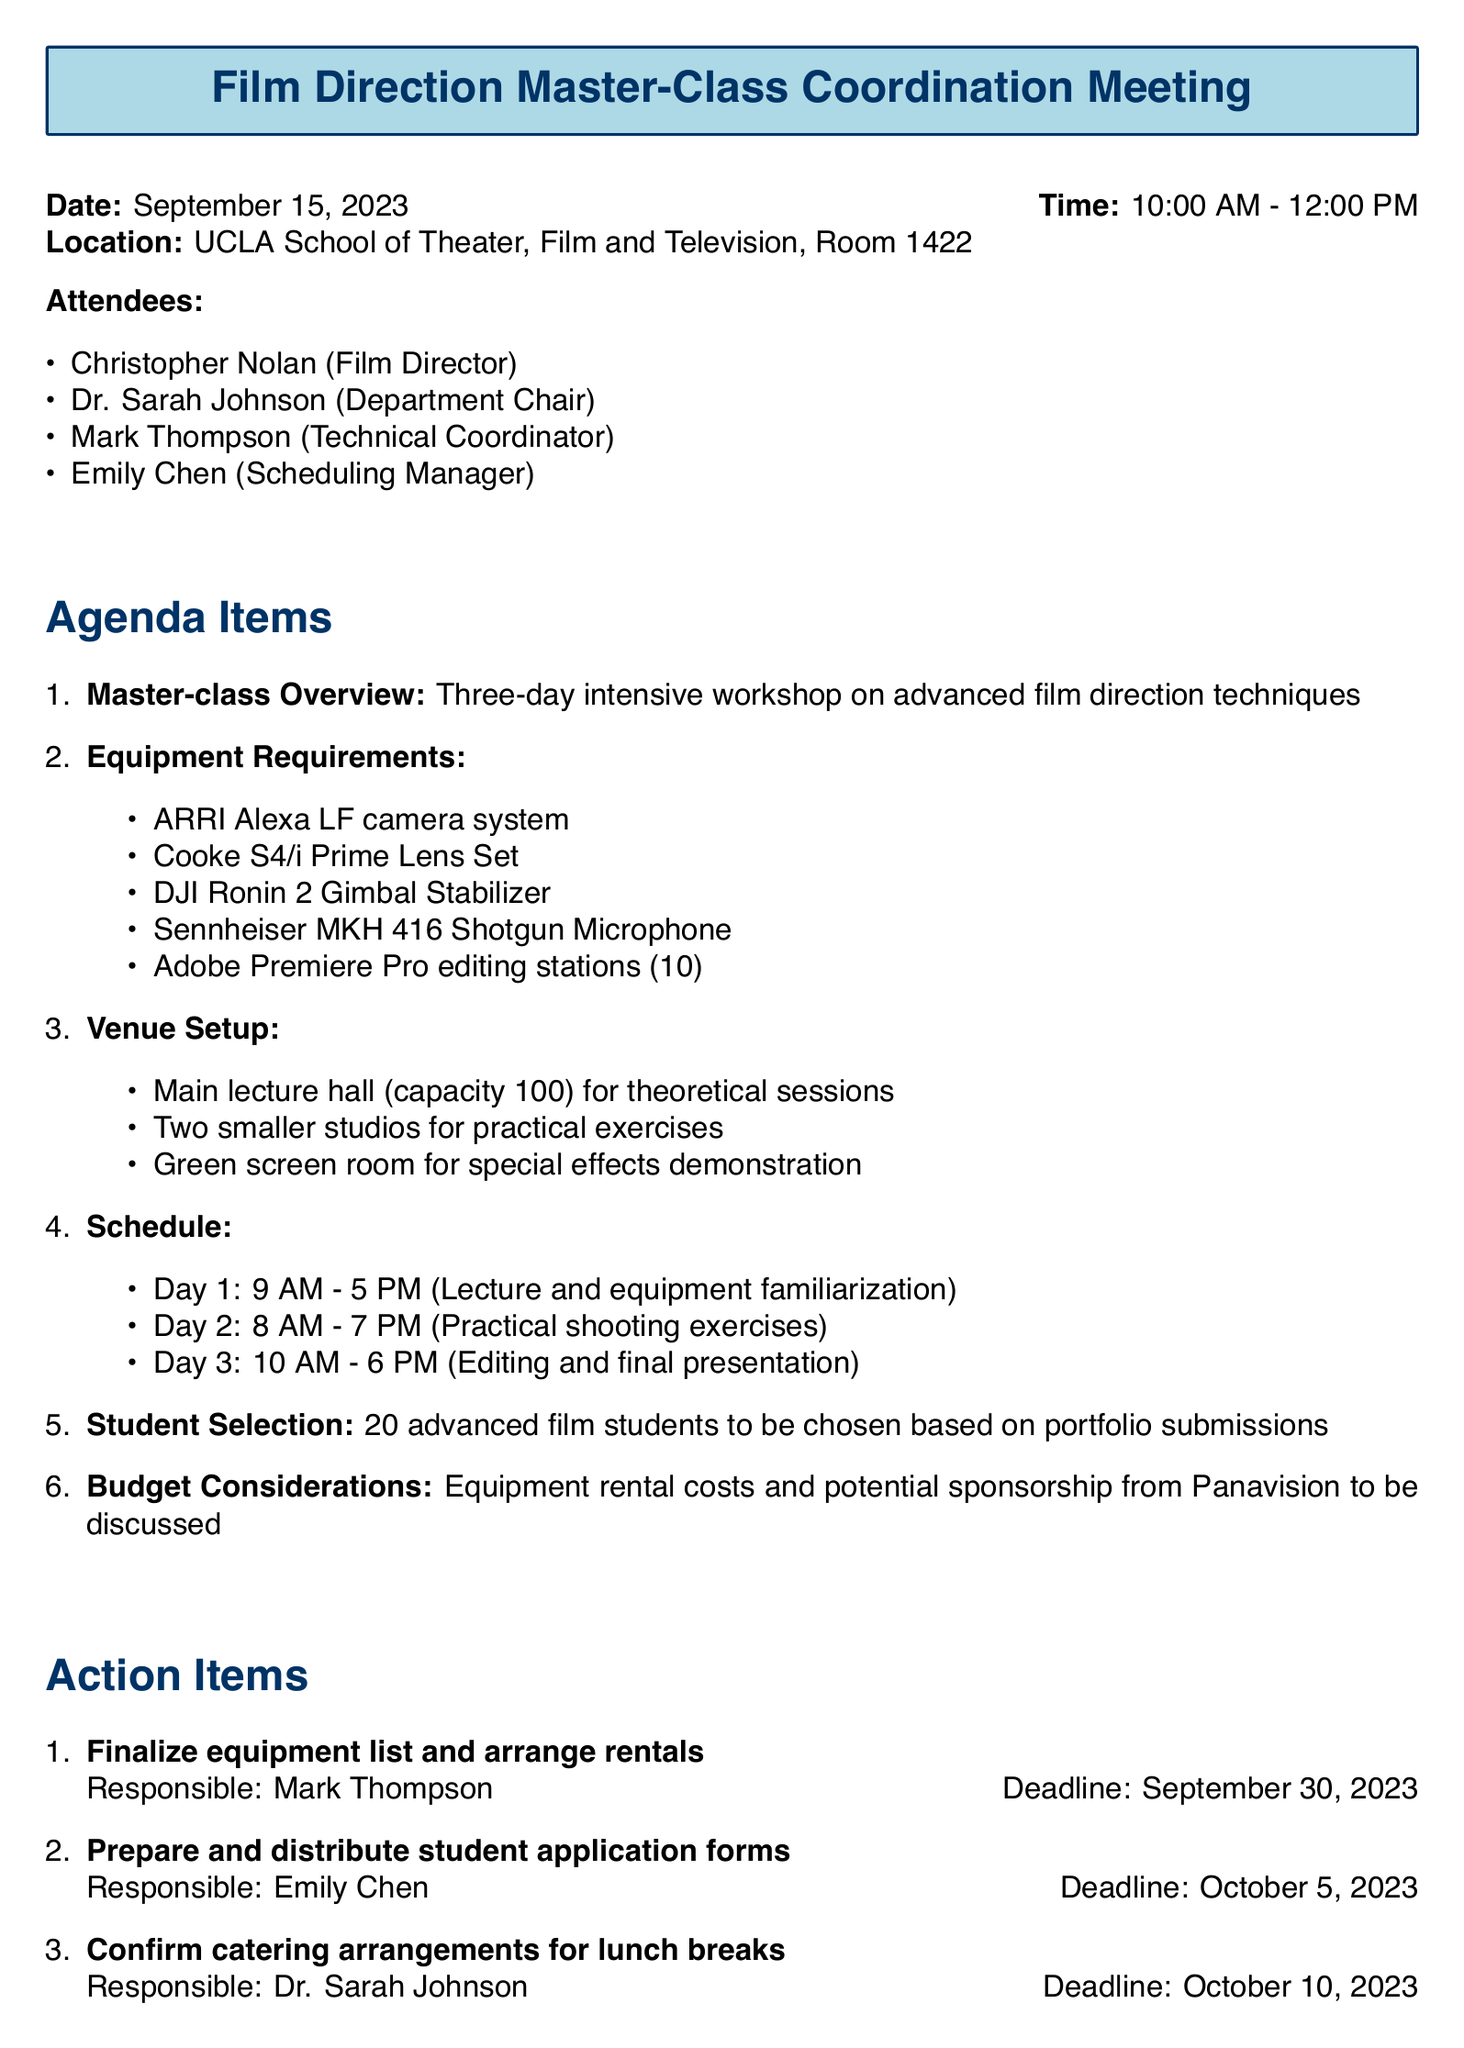What is the date of the meeting? The date of the meeting is explicitly stated in the document.
Answer: September 15, 2023 Who is responsible for finalizing the equipment list? The document lists the person responsible for this specific task.
Answer: Mark Thompson What is the capacity of the main lecture hall? This information can be found in the venue setup section of the document.
Answer: 100 What are the hours of Day 2 of the master-class? The document provides specific start and end times for each day in the schedule section.
Answer: 8 AM - 7 PM How many students will be selected for the master-class? The student selection section provides a specific number related to this query.
Answer: 20 Which equipment is needed for practical shooting exercises? Several specific items are listed in the equipment requirements that relate to this aspect.
Answer: DJI Ronin 2 Gimbal Stabilizer When is the deadline to prepare student application forms? The deadline for this task is noted in the action items section.
Answer: October 5, 2023 What is the time frame for Day 3 activities? The specifics of Day 3's schedule are given in the document and are relevant to this question.
Answer: 10 AM - 6 PM What is under the Budget Considerations agenda item? This section briefly outlines the financial aspects discussed in the meeting.
Answer: Equipment rental costs and potential sponsorship from Panavision to be discussed 